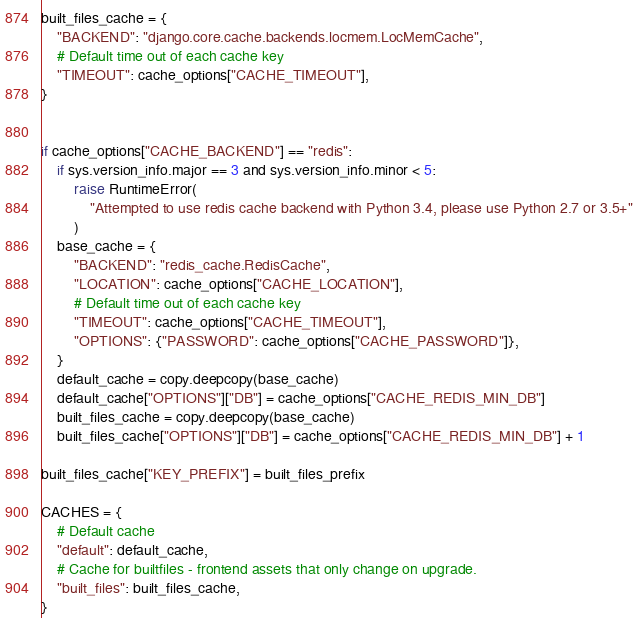Convert code to text. <code><loc_0><loc_0><loc_500><loc_500><_Python_>
built_files_cache = {
    "BACKEND": "django.core.cache.backends.locmem.LocMemCache",
    # Default time out of each cache key
    "TIMEOUT": cache_options["CACHE_TIMEOUT"],
}


if cache_options["CACHE_BACKEND"] == "redis":
    if sys.version_info.major == 3 and sys.version_info.minor < 5:
        raise RuntimeError(
            "Attempted to use redis cache backend with Python 3.4, please use Python 2.7 or 3.5+"
        )
    base_cache = {
        "BACKEND": "redis_cache.RedisCache",
        "LOCATION": cache_options["CACHE_LOCATION"],
        # Default time out of each cache key
        "TIMEOUT": cache_options["CACHE_TIMEOUT"],
        "OPTIONS": {"PASSWORD": cache_options["CACHE_PASSWORD"]},
    }
    default_cache = copy.deepcopy(base_cache)
    default_cache["OPTIONS"]["DB"] = cache_options["CACHE_REDIS_MIN_DB"]
    built_files_cache = copy.deepcopy(base_cache)
    built_files_cache["OPTIONS"]["DB"] = cache_options["CACHE_REDIS_MIN_DB"] + 1

built_files_cache["KEY_PREFIX"] = built_files_prefix

CACHES = {
    # Default cache
    "default": default_cache,
    # Cache for builtfiles - frontend assets that only change on upgrade.
    "built_files": built_files_cache,
}
</code> 